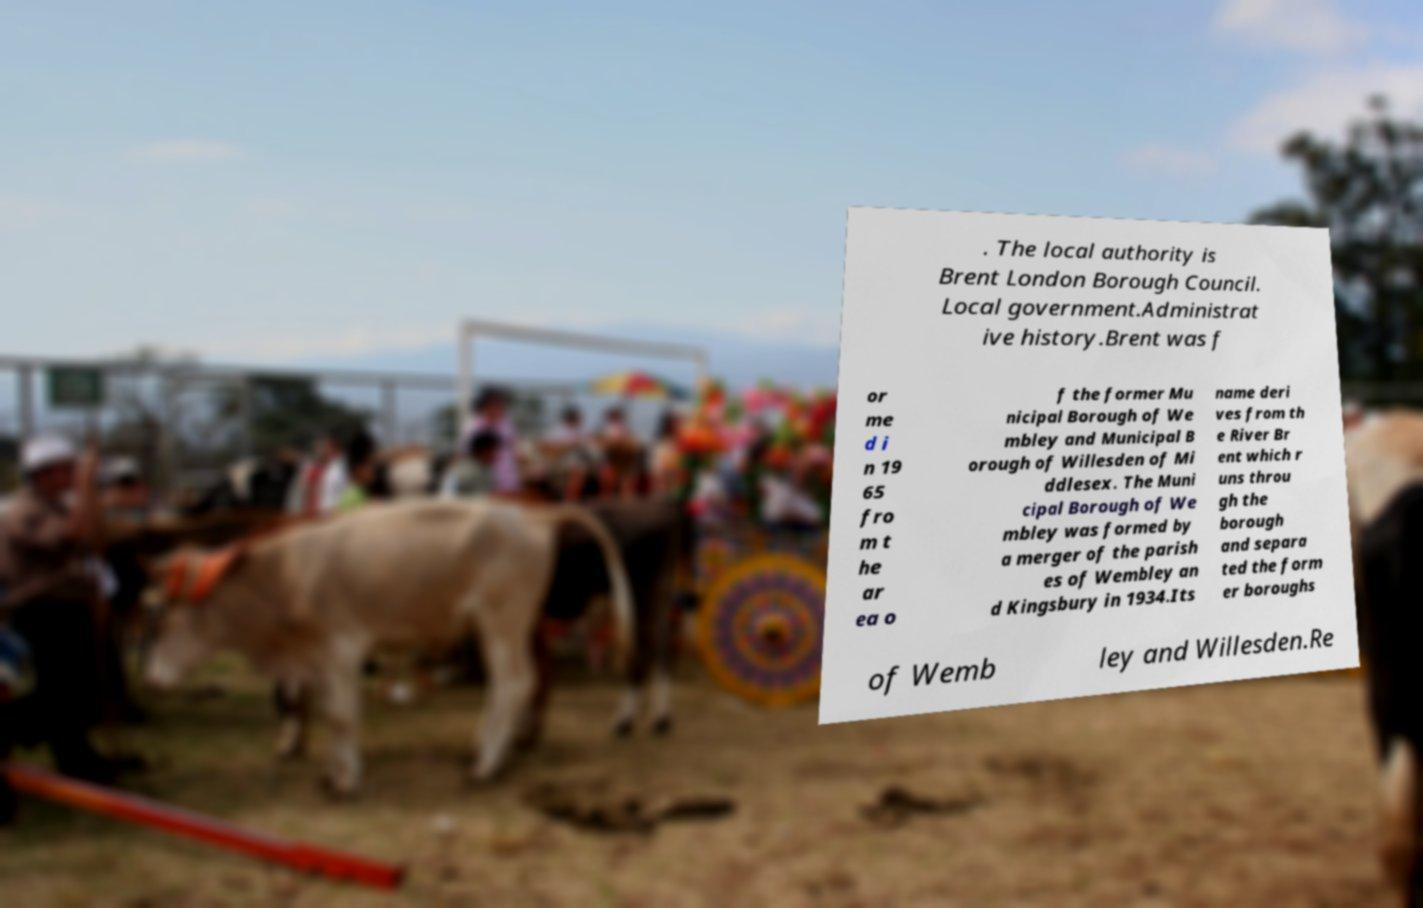Please identify and transcribe the text found in this image. . The local authority is Brent London Borough Council. Local government.Administrat ive history.Brent was f or me d i n 19 65 fro m t he ar ea o f the former Mu nicipal Borough of We mbley and Municipal B orough of Willesden of Mi ddlesex. The Muni cipal Borough of We mbley was formed by a merger of the parish es of Wembley an d Kingsbury in 1934.Its name deri ves from th e River Br ent which r uns throu gh the borough and separa ted the form er boroughs of Wemb ley and Willesden.Re 